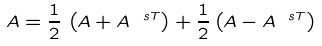Convert formula to latex. <formula><loc_0><loc_0><loc_500><loc_500>A = \frac { 1 } { 2 } \, \left ( A + A ^ { \ s T } \right ) + \frac { 1 } { 2 } \left ( A - A ^ { \ s T } \right )</formula> 